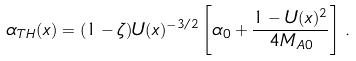<formula> <loc_0><loc_0><loc_500><loc_500>\alpha _ { T H } ( x ) = ( 1 - \zeta ) U ( x ) ^ { - 3 / 2 } \left [ \alpha _ { 0 } + \frac { 1 - U ( x ) ^ { 2 } } { 4 M _ { A 0 } } \right ] \, .</formula> 